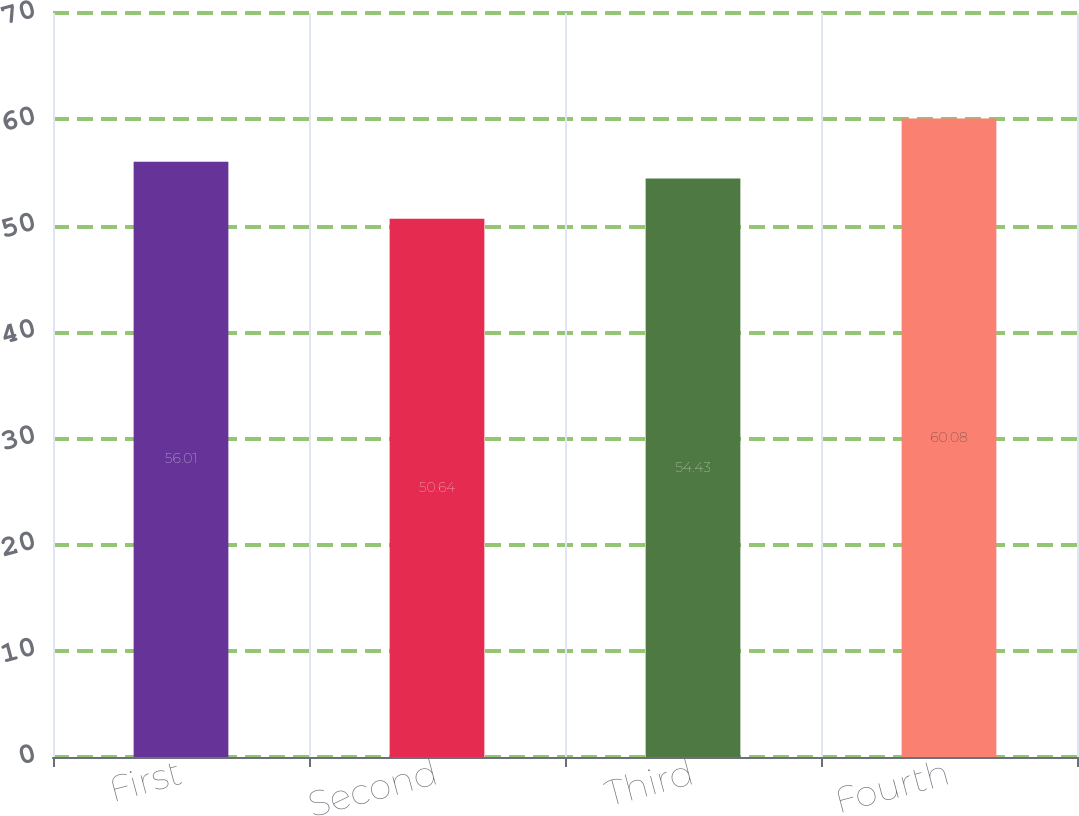Convert chart to OTSL. <chart><loc_0><loc_0><loc_500><loc_500><bar_chart><fcel>First<fcel>Second<fcel>Third<fcel>Fourth<nl><fcel>56.01<fcel>50.64<fcel>54.43<fcel>60.08<nl></chart> 